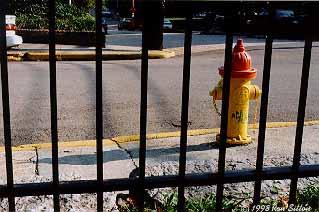What year was this photo taken?
Be succinct. 1998. What color is the hydrant?
Answer briefly. Yellow and red. Is the gate too close to the fire hydrant?
Answer briefly. No. 